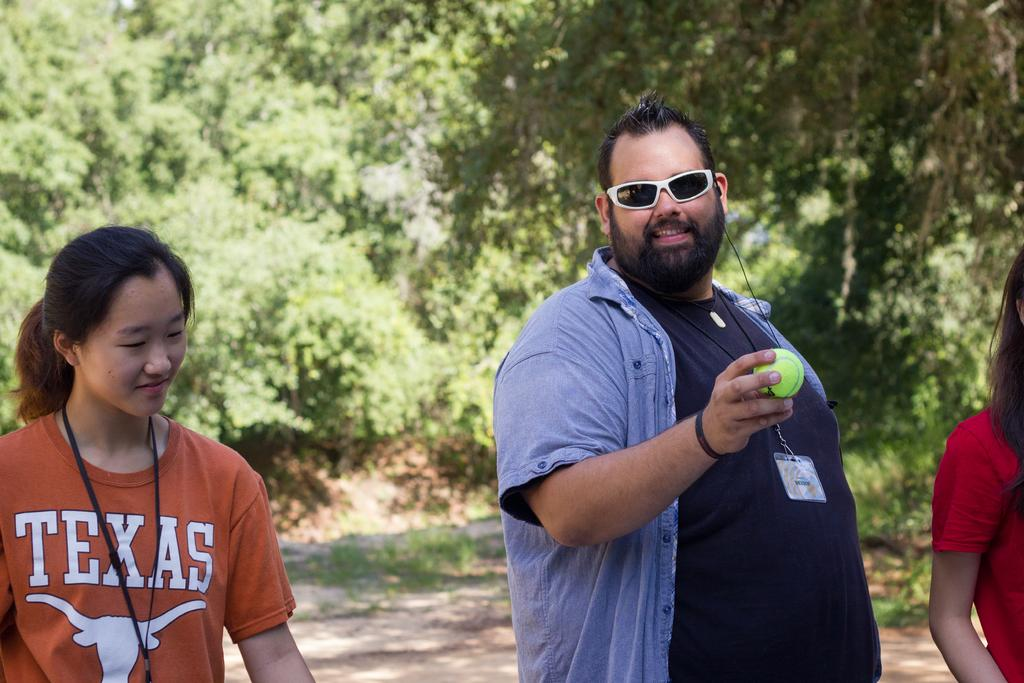What can be seen in the image? There are people in the image. Can you describe the man in the image? There is a man holding a ball in the image, and he is wearing glasses. What is visible in the background of the image? There are trees visible in the background of the image. What type of gold object is the man holding in the image? The man is not holding a gold object in the image; he is holding a ball. What is the man's occupation, and is he accompanied by his army in the image? There is no information about the man's occupation or the presence of an army in the image. 